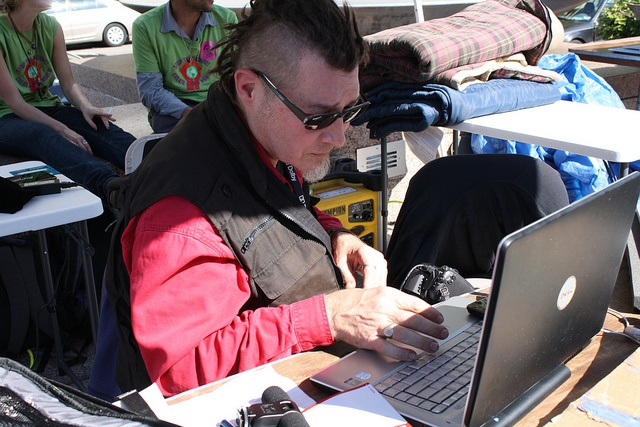Describe the objects in this image and their specific colors. I can see people in gray, black, and lightpink tones, laptop in gray and black tones, people in gray, black, darkgreen, and maroon tones, people in gray, teal, black, darkgreen, and purple tones, and car in gray, white, darkgray, and lightblue tones in this image. 